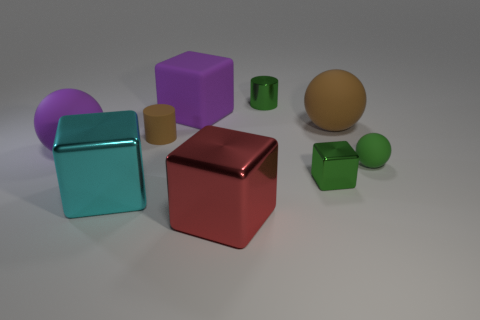Which object in the image appears to be the largest? The largest object in the image seems to be the red cube in the foreground. It appears significantly larger in size compared to the other objects. 